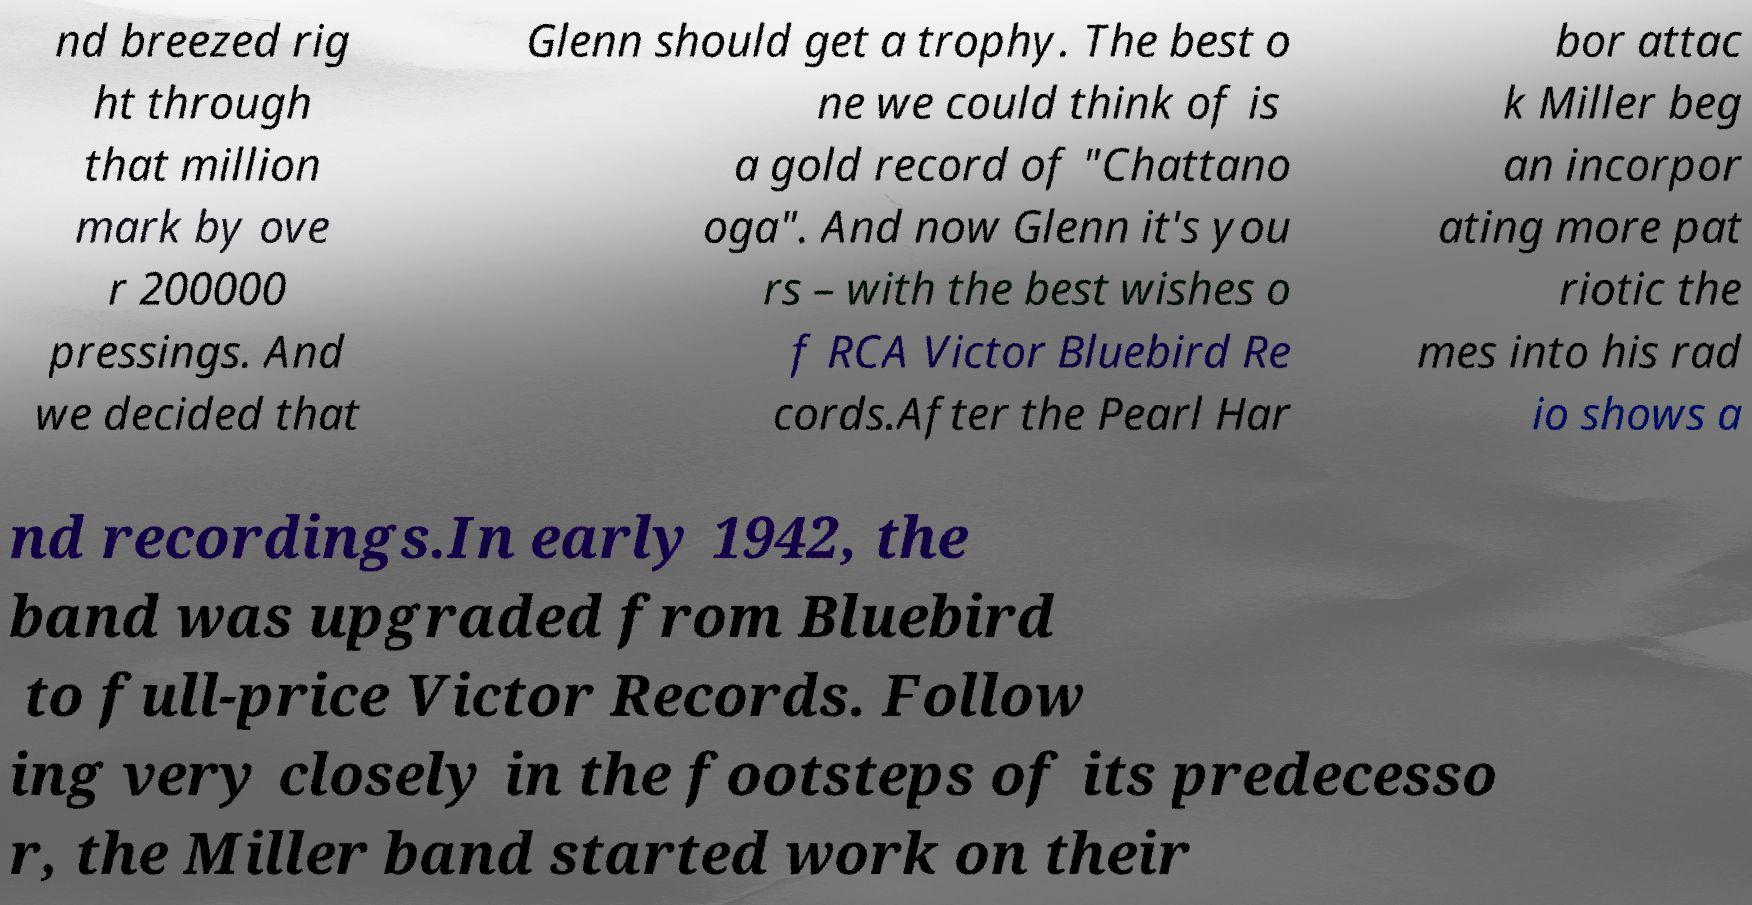What messages or text are displayed in this image? I need them in a readable, typed format. nd breezed rig ht through that million mark by ove r 200000 pressings. And we decided that Glenn should get a trophy. The best o ne we could think of is a gold record of "Chattano oga". And now Glenn it's you rs – with the best wishes o f RCA Victor Bluebird Re cords.After the Pearl Har bor attac k Miller beg an incorpor ating more pat riotic the mes into his rad io shows a nd recordings.In early 1942, the band was upgraded from Bluebird to full-price Victor Records. Follow ing very closely in the footsteps of its predecesso r, the Miller band started work on their 